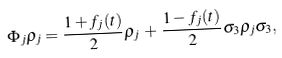Convert formula to latex. <formula><loc_0><loc_0><loc_500><loc_500>\Phi _ { j } \rho _ { j } = { \frac { 1 + f _ { j } ( t ) } { 2 } } \rho _ { j } \, + \, { \frac { 1 - f _ { j } ( t ) } { 2 } } \sigma _ { 3 } \rho _ { j } \sigma _ { 3 } ,</formula> 